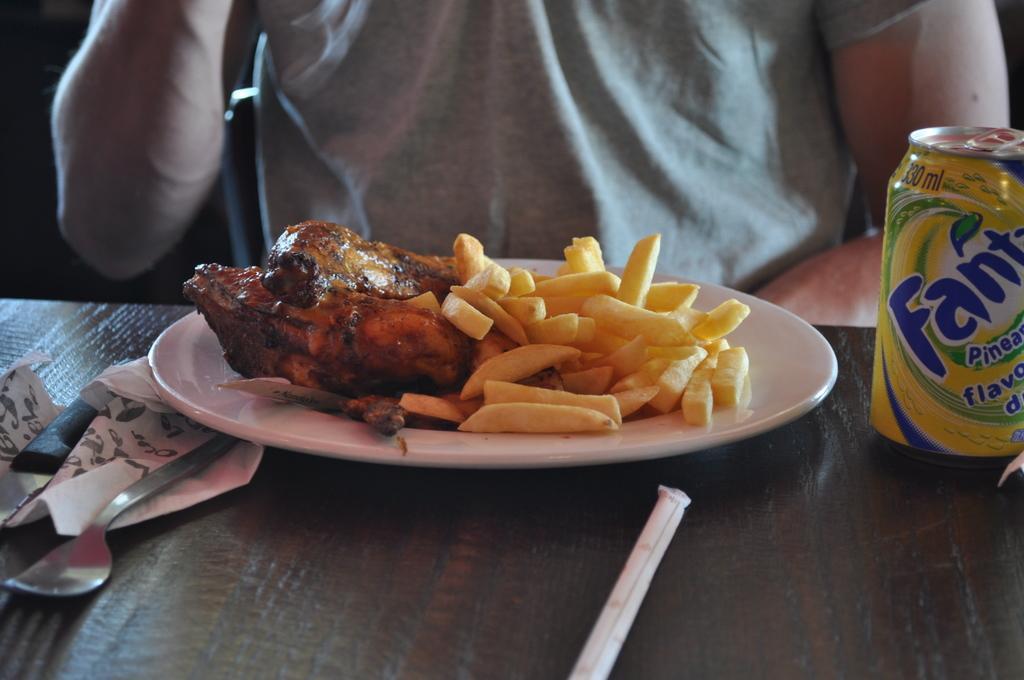Could you give a brief overview of what you see in this image? In this picture I can see food items on the plate, there is a spoon, knife, tin and some other objects, on the table, and in the background there is a person. 